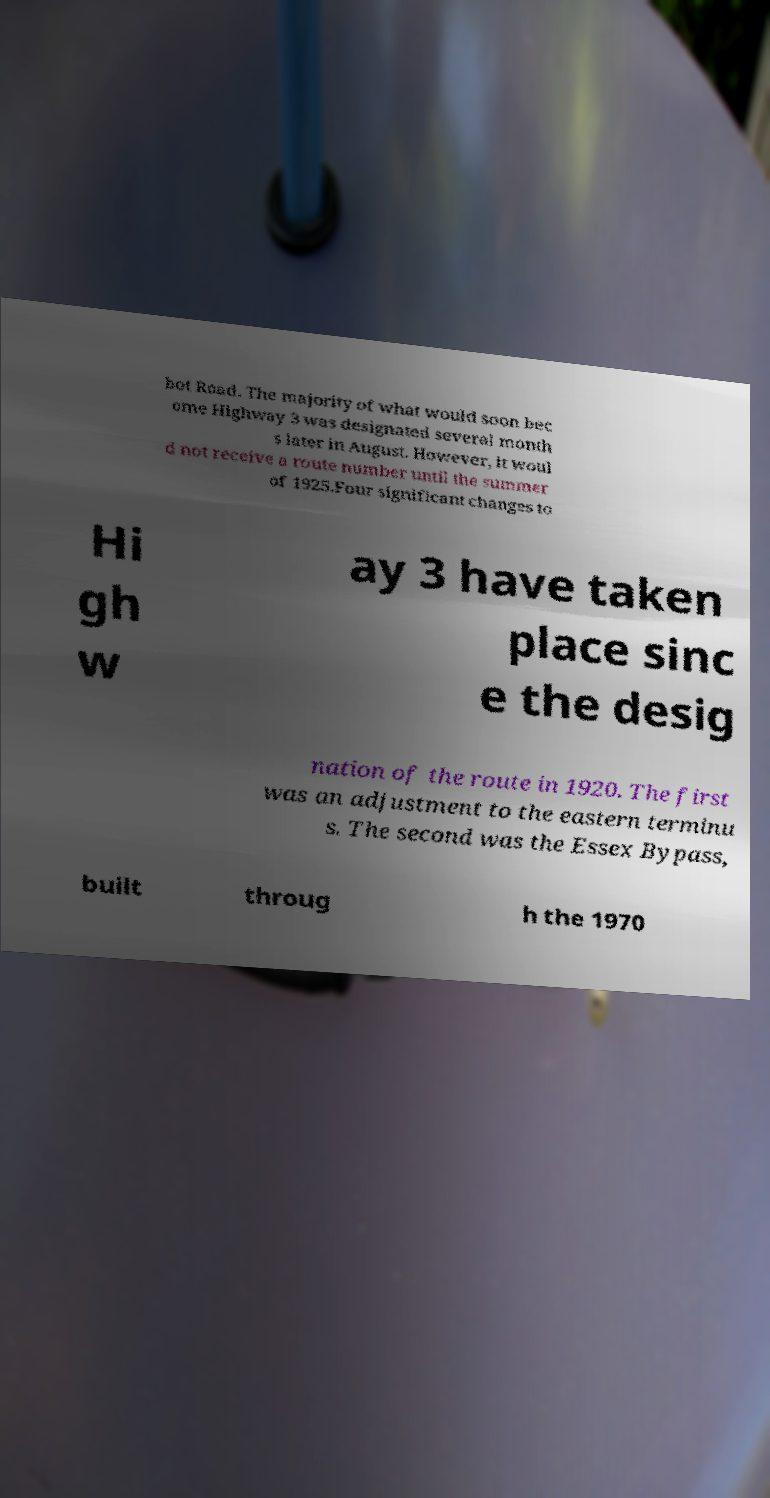Please identify and transcribe the text found in this image. bot Road. The majority of what would soon bec ome Highway 3 was designated several month s later in August. However, it woul d not receive a route number until the summer of 1925.Four significant changes to Hi gh w ay 3 have taken place sinc e the desig nation of the route in 1920. The first was an adjustment to the eastern terminu s. The second was the Essex Bypass, built throug h the 1970 